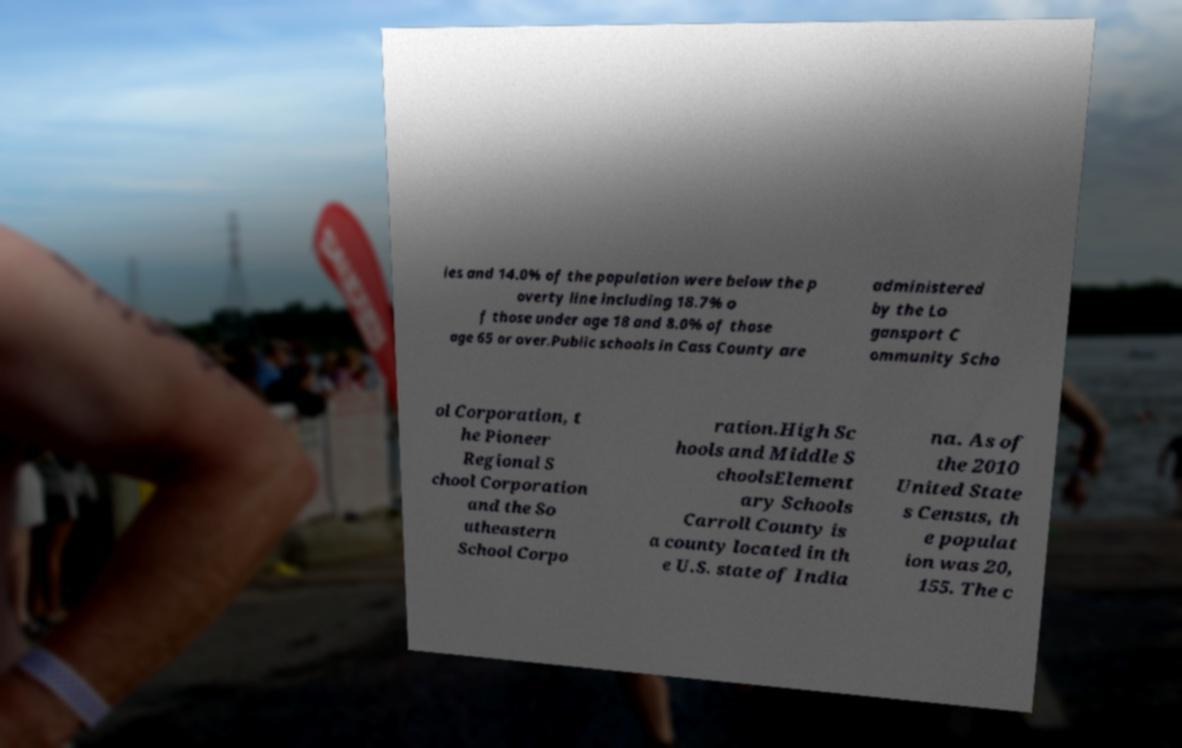Please read and relay the text visible in this image. What does it say? ies and 14.0% of the population were below the p overty line including 18.7% o f those under age 18 and 8.0% of those age 65 or over.Public schools in Cass County are administered by the Lo gansport C ommunity Scho ol Corporation, t he Pioneer Regional S chool Corporation and the So utheastern School Corpo ration.High Sc hools and Middle S choolsElement ary Schools Carroll County is a county located in th e U.S. state of India na. As of the 2010 United State s Census, th e populat ion was 20, 155. The c 